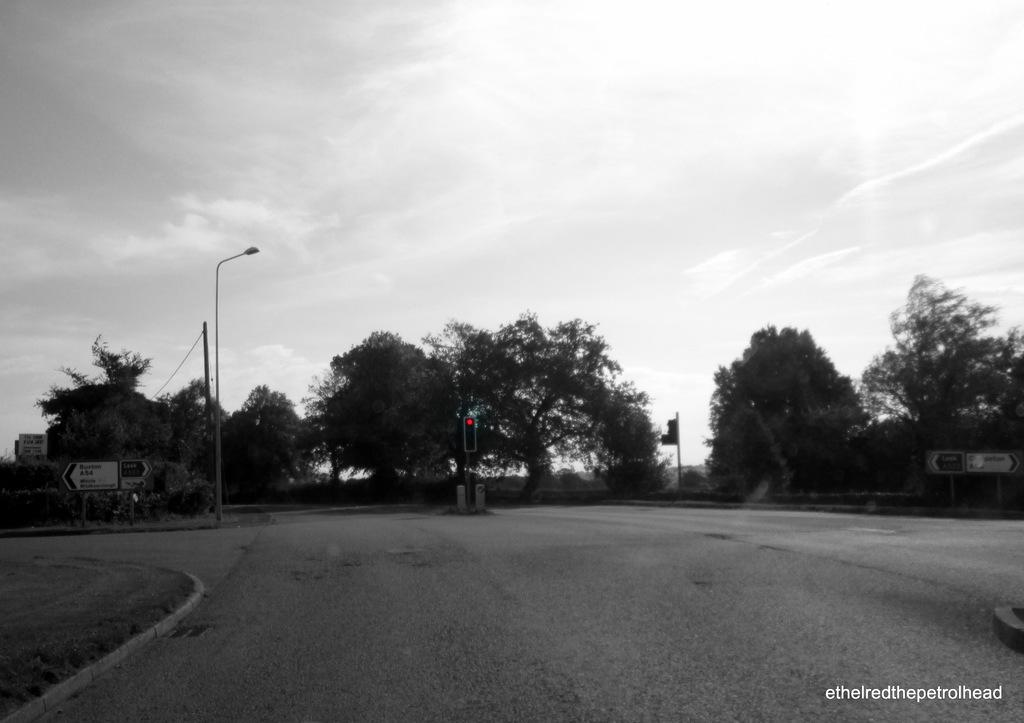What is the main feature of the image? There is a road in the image. What can be seen controlling the traffic on the road? Traffic lights are present in the image. What are the vertical structures supporting the traffic lights and sign boards? Street poles are visible in the image. What type of information is displayed for drivers and pedestrians? Sign boards are in the image. What can be seen in the distance behind the road? There are trees in the background of the image. What is visible above the trees and sign boards? The sky is visible in the background of the image, and it appears cloudy. Can you see a brush being used for a haircut in the image? There is no brush or haircut visible in the image; it features a road, traffic lights, street poles, sign boards, trees, and a cloudy sky. 